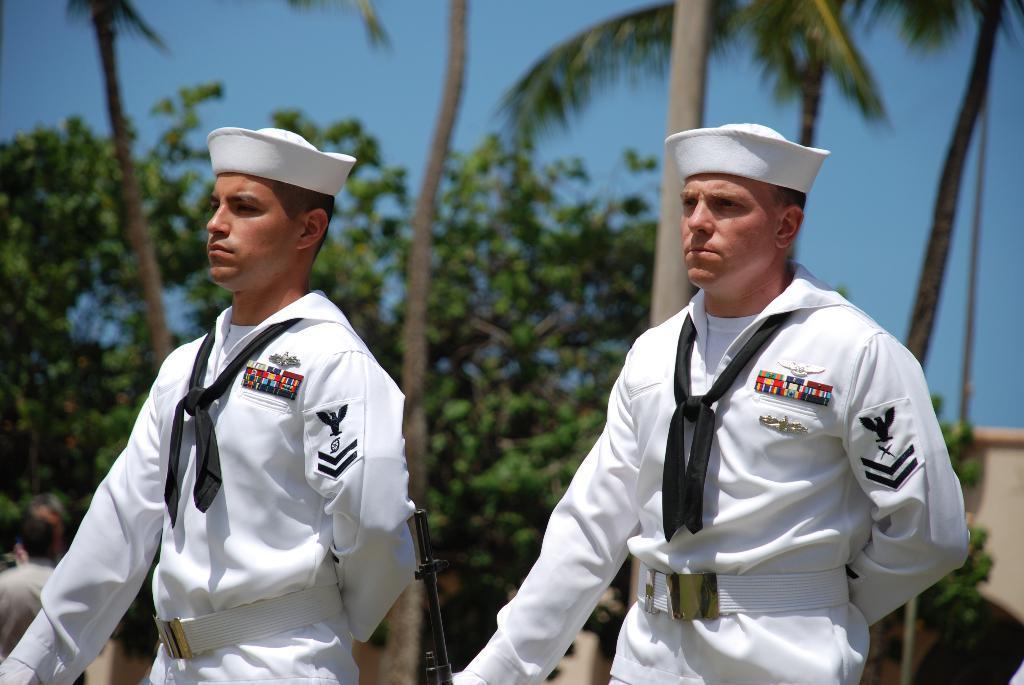How would you summarize this image in a sentence or two? In this image there are two navy officers wearing a white color dress and the white hat on the head, standing with the black color guns. Behind there are some coconut tree and plants. 